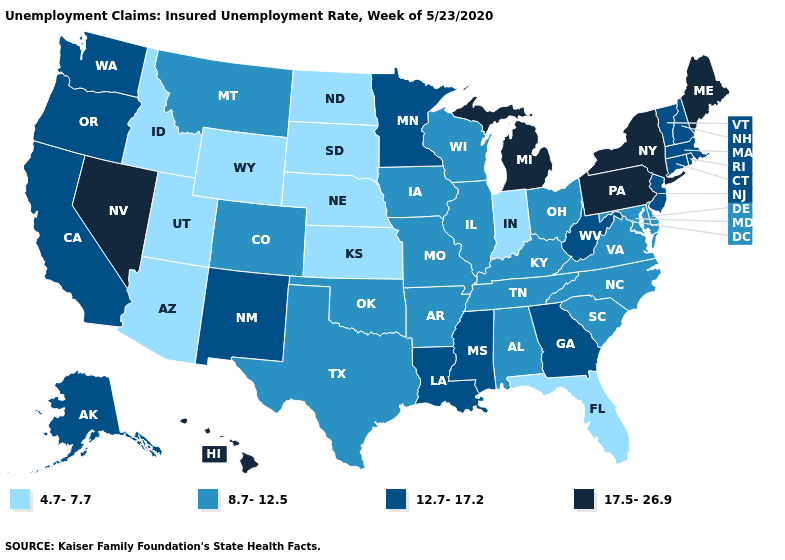Name the states that have a value in the range 12.7-17.2?
Write a very short answer. Alaska, California, Connecticut, Georgia, Louisiana, Massachusetts, Minnesota, Mississippi, New Hampshire, New Jersey, New Mexico, Oregon, Rhode Island, Vermont, Washington, West Virginia. What is the highest value in states that border Nebraska?
Short answer required. 8.7-12.5. Which states have the highest value in the USA?
Write a very short answer. Hawaii, Maine, Michigan, Nevada, New York, Pennsylvania. What is the value of Idaho?
Keep it brief. 4.7-7.7. Name the states that have a value in the range 4.7-7.7?
Give a very brief answer. Arizona, Florida, Idaho, Indiana, Kansas, Nebraska, North Dakota, South Dakota, Utah, Wyoming. What is the value of Pennsylvania?
Be succinct. 17.5-26.9. Among the states that border West Virginia , which have the lowest value?
Quick response, please. Kentucky, Maryland, Ohio, Virginia. What is the value of Nevada?
Short answer required. 17.5-26.9. Does Vermont have a higher value than Texas?
Be succinct. Yes. What is the highest value in the USA?
Quick response, please. 17.5-26.9. What is the value of Mississippi?
Be succinct. 12.7-17.2. Among the states that border Illinois , which have the highest value?
Write a very short answer. Iowa, Kentucky, Missouri, Wisconsin. Does Minnesota have a higher value than Alabama?
Be succinct. Yes. Does North Dakota have a higher value than Florida?
Give a very brief answer. No. 